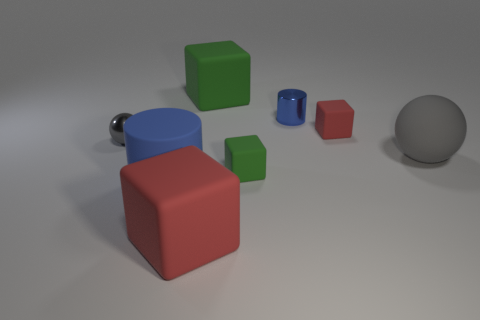Is there an indication of what the large blue cube with a knob might be used for? There isn't a clear indication of its intended use solely from the image. The large blue cube with a knob could be a minimalist representation of some furniture with a drawer or possibly a child's toy designed to stimulate learning through shapes and mechanics. Could it have a functional purpose? It's possible; if the knob is functional and the cube is hollow, it could serve as a basic form of storage similar to a drawer. Its purpose might be better understood within the context of its surrounding items or environment, which is not visible here. 